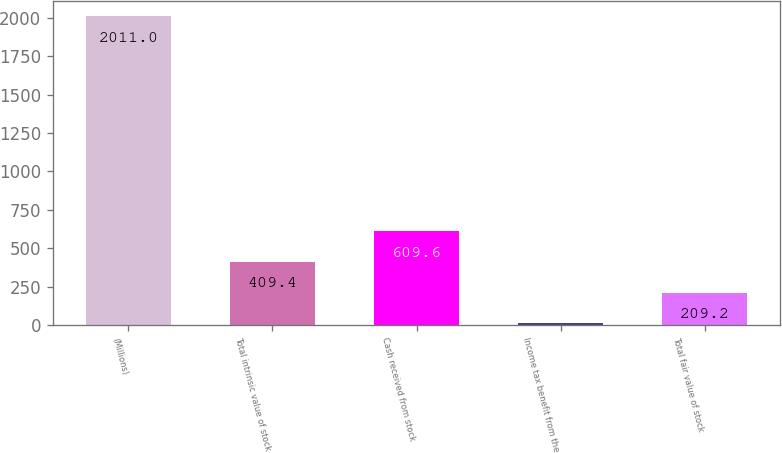Convert chart. <chart><loc_0><loc_0><loc_500><loc_500><bar_chart><fcel>(Millions)<fcel>Total intrinsic value of stock<fcel>Cash received from stock<fcel>Income tax benefit from the<fcel>Total fair value of stock<nl><fcel>2011<fcel>409.4<fcel>609.6<fcel>9<fcel>209.2<nl></chart> 